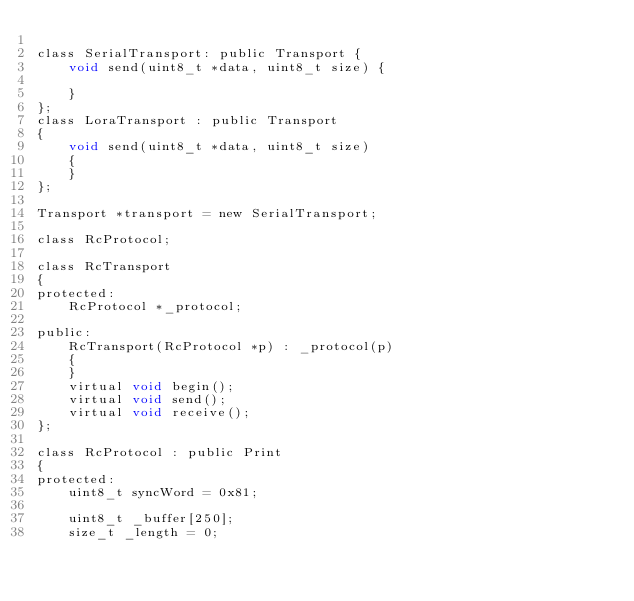Convert code to text. <code><loc_0><loc_0><loc_500><loc_500><_C_>
class SerialTransport: public Transport {
    void send(uint8_t *data, uint8_t size) {

    }
};
class LoraTransport : public Transport
{
    void send(uint8_t *data, uint8_t size)
    {
    }
};
                
Transport *transport = new SerialTransport;

class RcProtocol;

class RcTransport
{
protected:
    RcProtocol *_protocol;

public:
    RcTransport(RcProtocol *p) : _protocol(p)
    {
    }
    virtual void begin();
    virtual void send();
    virtual void receive();
};

class RcProtocol : public Print
{
protected:
    uint8_t syncWord = 0x81;

    uint8_t _buffer[250];
    size_t _length = 0;</code> 